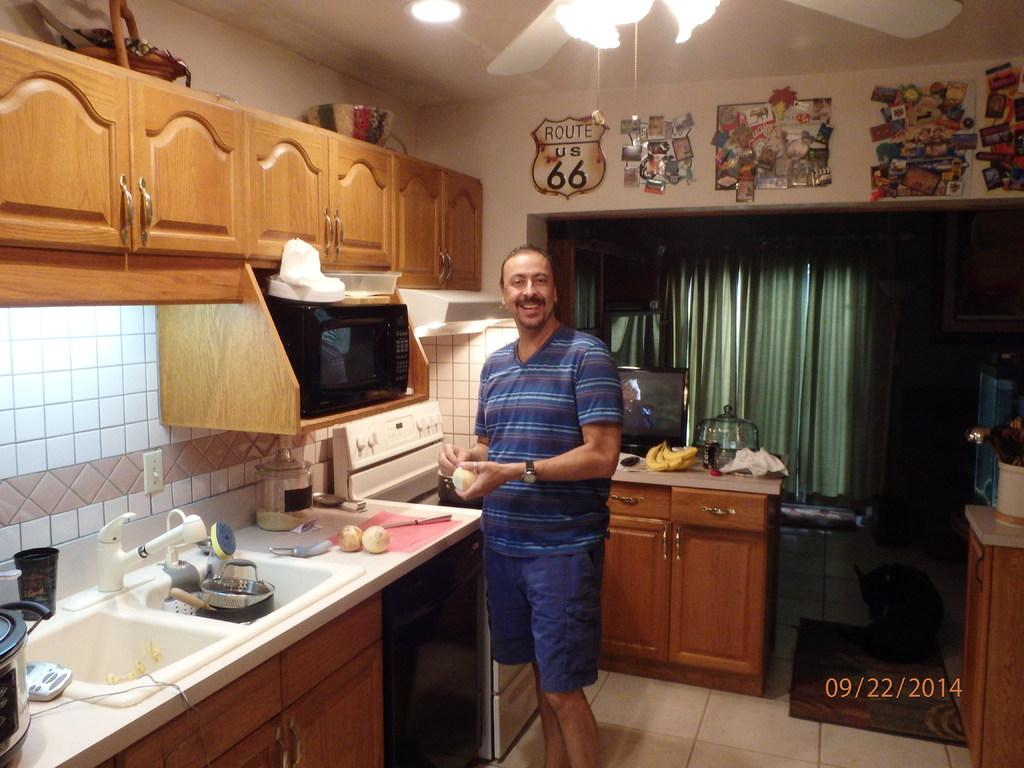<image>
Share a concise interpretation of the image provided. a man smiling for a picture in a kitchen on 09/22/2014 